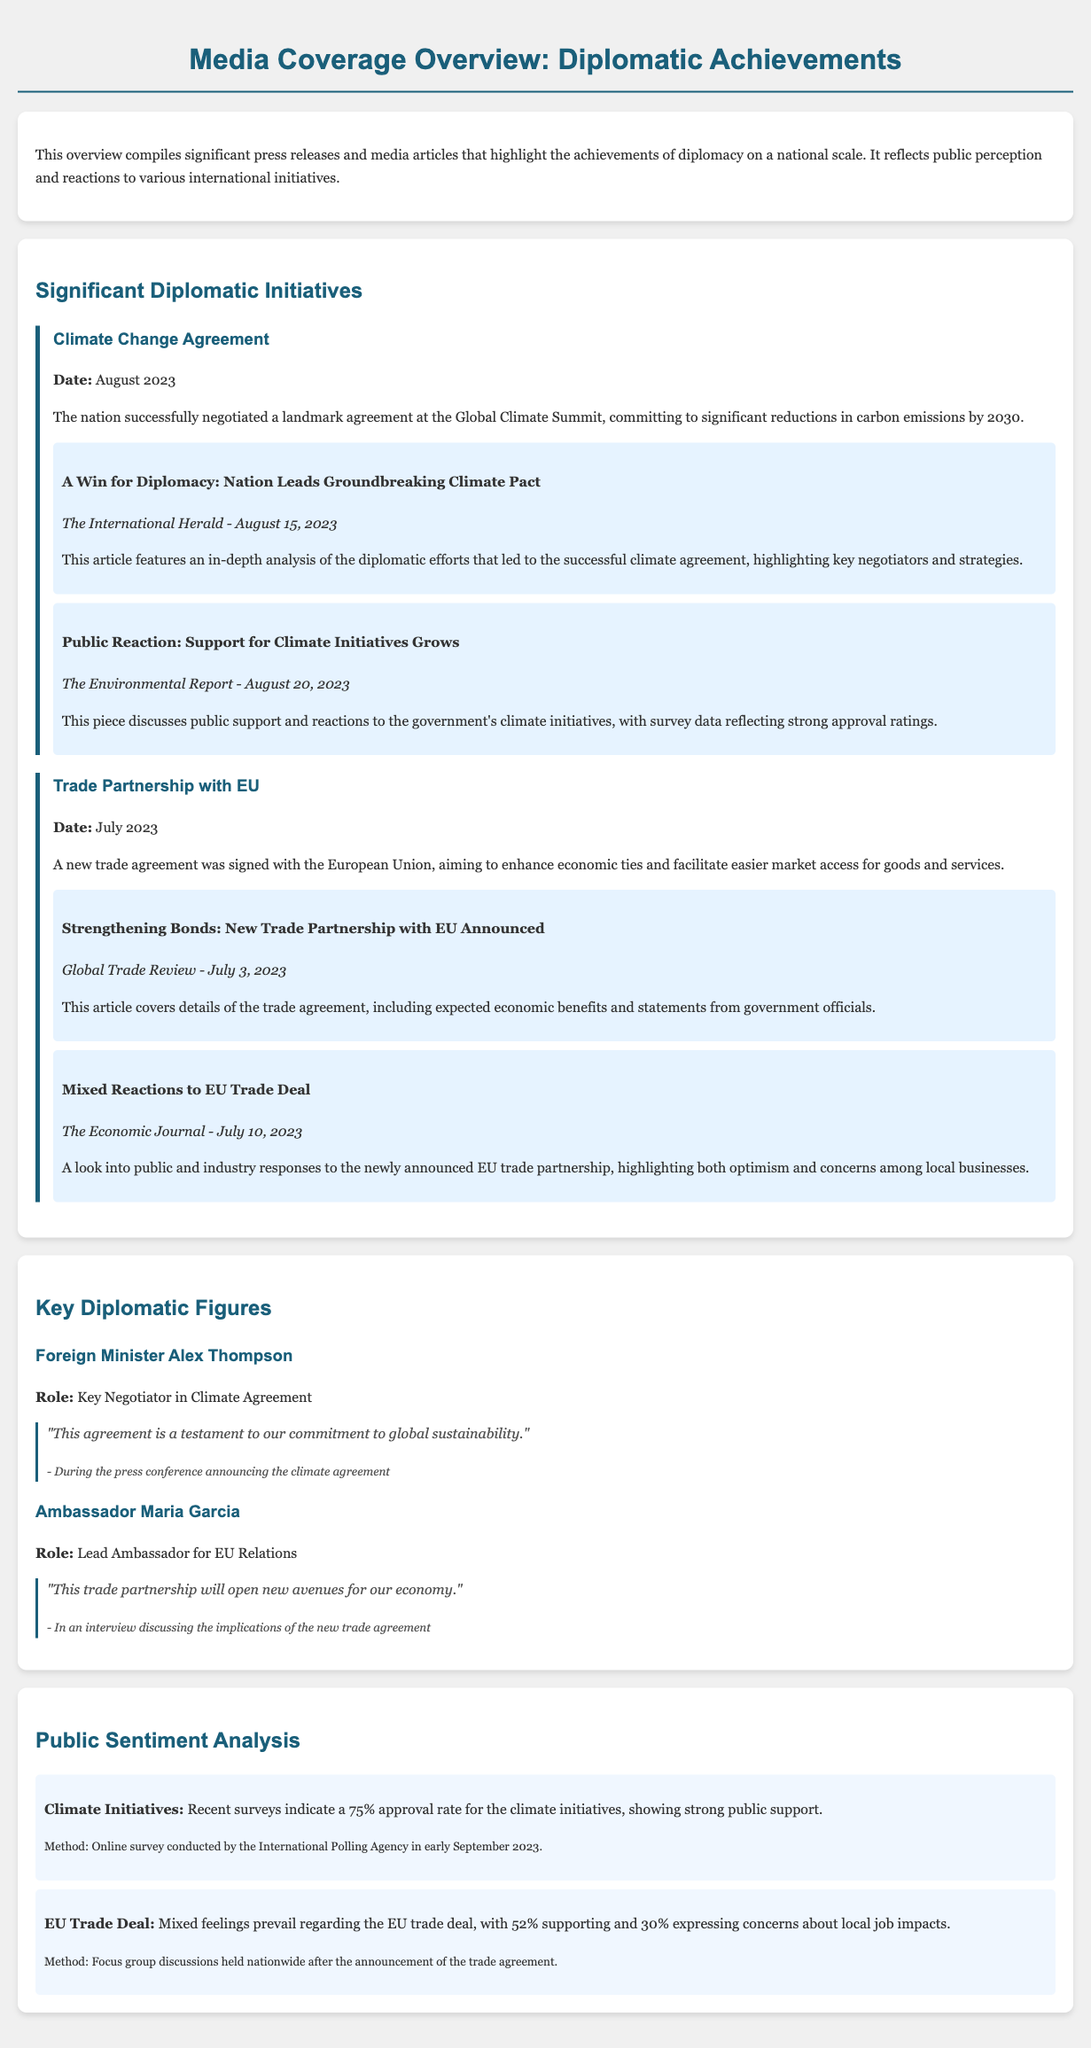What was the date of the Climate Change Agreement? The date is specified in the document, indicating when the Climate Change Agreement was signed.
Answer: August 2023 Who is the lead ambassador for EU Relations? The document provides information about key diplomatic figures and their roles, including the lead ambassador's name.
Answer: Maria Garcia What percentage of public approval is there for Climate Initiatives? The document includes survey results that quantify public sentiment regarding the Climate Initiatives.
Answer: 75% What was the primary goal of the trade partnership with the EU? The document outlines the objectives of the trade partnership, which reflects its intention to enhance specific economic measures.
Answer: Enhance economic ties What are the mixed feelings regarding the EU trade deal? The document captures public sentiment regarding the EU trade deal, specifying the differing opinions among constituents.
Answer: 52% supporting and 30% expressing concerns What publication featured the article “A Win for Diplomacy: Nation Leads Groundbreaking Climate Pact”? The document lists the media articles along with their respective sources, making it clear which publication provided the coverage.
Answer: The International Herald What method was used for the public sentiment analysis of Climate Initiatives? The document indicates the methodology used to gather public opinions on the Climate Initiatives, specifying the type of survey conducted.
Answer: Online survey What significant achievement is emphasized in the articles about the Climate Change Agreement? The document describes key diplomatic activities and their outcomes, highlighting the importance of a specific agreement.
Answer: Negotiated a landmark agreement Who made the statement about the commitment to global sustainability? The document quotes key diplomatic figures, clearly attributing a notable statement to one of them.
Answer: Alex Thompson 